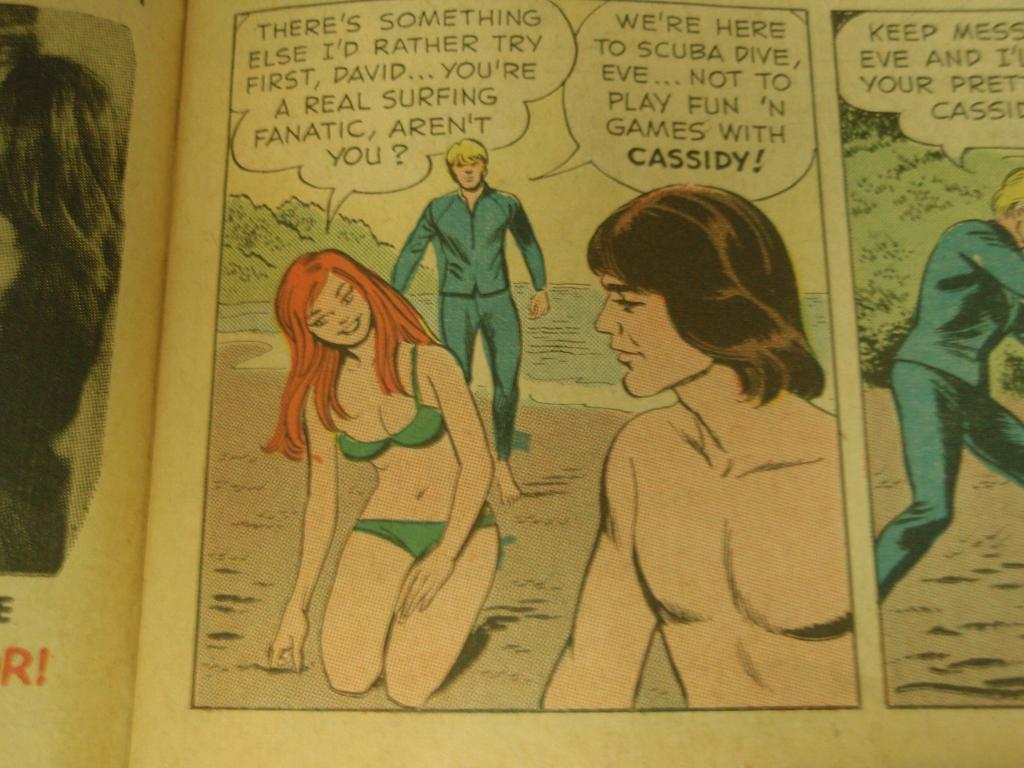According to the man in blue, who is eve not here to play fun and games with?
Ensure brevity in your answer.  Cassidy. What is the name of the shirtless man?
Keep it short and to the point. David. 